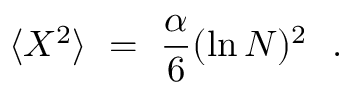<formula> <loc_0><loc_0><loc_500><loc_500>\langle X ^ { 2 } \rangle = \frac { \alpha } { 6 } ( \ln N ) ^ { 2 } .</formula> 